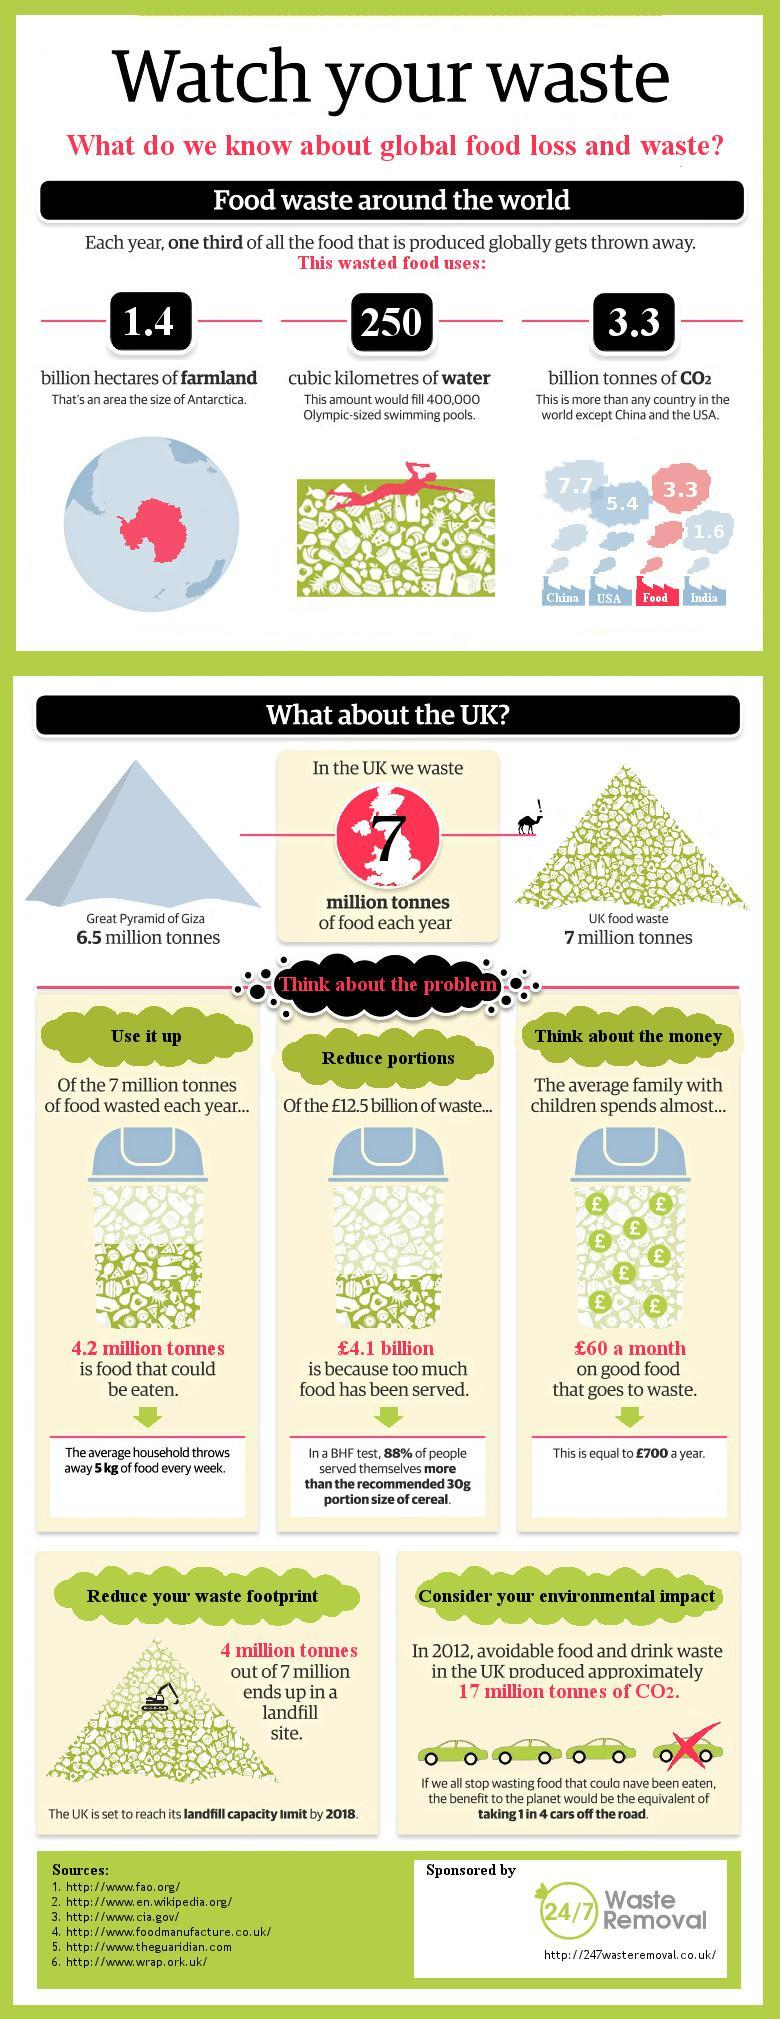Which country produces the most CO2 in the world?
Answer the question with a short phrase. China 